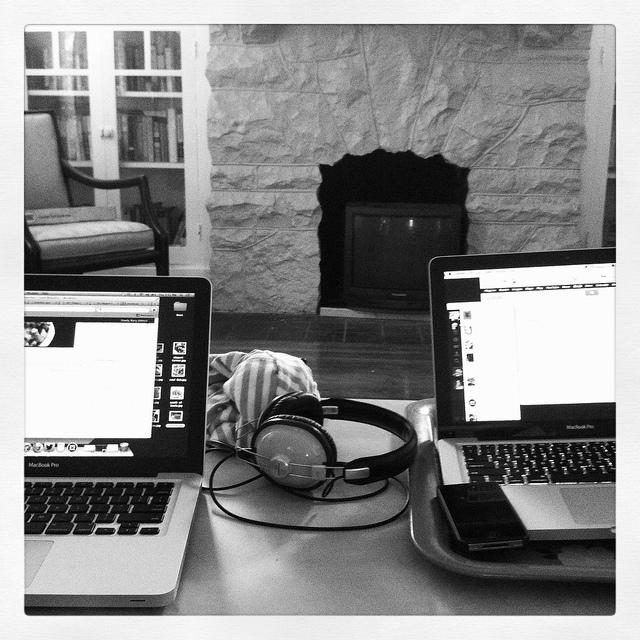What is inside the fireplace?
Write a very short answer. Tv. Where is the phone?
Give a very brief answer. On right laptop. How many computers are shown?
Give a very brief answer. 2. Is there a camera in the picture?
Give a very brief answer. No. 